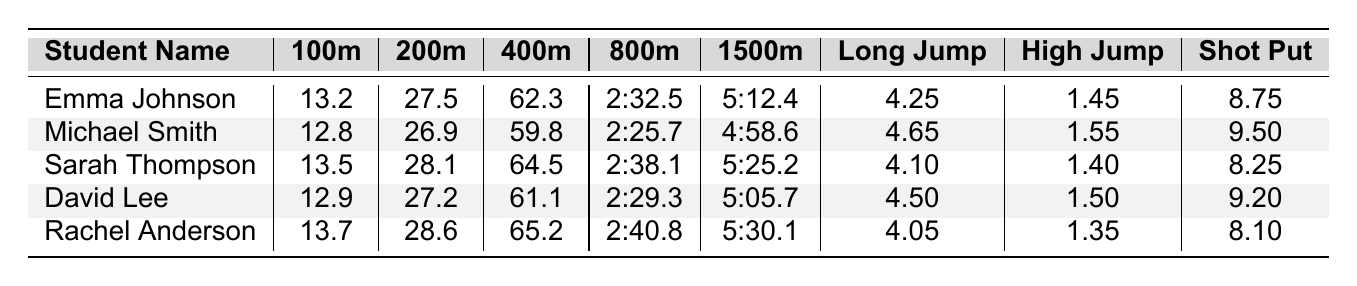What was Emma Johnson's time in the 400m run? Referring to the table, Emma Johnson's time in the 400m run is listed directly as 62.3 seconds.
Answer: 62.3 seconds Which student had the best performance in the long jump? Looking at the long jump column, Michael Smith has the highest value at 4.65 meters compared to all other students.
Answer: Michael Smith What was the average time for the 800m run? To find the average, add up all the times: 2:32.5 + 2:25.7 + 2:38.1 + 2:29.3 + 2:40.8 = 12:46.4. Convert this to seconds: (2*60 + 32.5) + (2*60 + 25.7) + (2*60 + 38.1) + (2*60 + 29.3) + (2*60 + 40.8) = 765.4 seconds. Divide by 5 to get the average: 765.4 / 5 = 153.08 seconds, which is 2 minutes 33.08 seconds.
Answer: 2:33.08 Is Rachel Anderson the fastest in the 200m sprint? In the 200m sprint column, the fastest recorded time is Michael Smith’s 26.9 seconds, which is less than Rachel Anderson’s 28.6 seconds, so she is not the fastest.
Answer: No Which two students had times within 2 seconds of each other in the 1500m run? Checking the 1500m times, David Lee (5:05.7) and Michael Smith (4:58.6) have times that differ by just 7.1 seconds. Looking for pairs within a closer range, only Emma Johnson (5:12.4) and Sarah Thompson (5:25.2) are approximately 13 seconds apart, but none are truly within 2 seconds. No pairs fit this criterion.
Answer: None What is the difference in performance for the shot put between Michael Smith and Sarah Thompson? Michael Smith's shot put performance is 9.50 meters while Sarah Thompson's is 8.25 meters. The difference is 9.50 - 8.25 = 1.25 meters.
Answer: 1.25 meters Who had the second-best time in the 100m sprint? The 100m sprint times show that Michael Smith has the best time (12.8 seconds). The second-best time is Emma Johnson's 13.2 seconds when compared to others.
Answer: Emma Johnson If we exclude the slowest time in the high jump, what is the average height for the remaining students? The heights excluding the slowest (Rachel Anderson's 1.35m) are 1.45m, 1.55m, and 1.50m. The total of these heights is 1.45 + 1.55 + 1.50 = 4.50 meters. Divide by 3, giving an average height of 1.50m.
Answer: 1.50 meters Which track event did Sarah Thompson perform best in? Referring to the table entries for Sarah Thompson, her best performance is in the high jump, achieving 1.40 meters, compared to her other event times, which are higher.
Answer: High Jump How much faster was David Lee than Rachel Anderson in the 400m run? David Lee's time in the 400m run is 61.1 seconds while Rachel Anderson's is 65.2 seconds. The difference is 65.2 - 61.1 = 4.1 seconds, showing David was quicker.
Answer: 4.1 seconds 